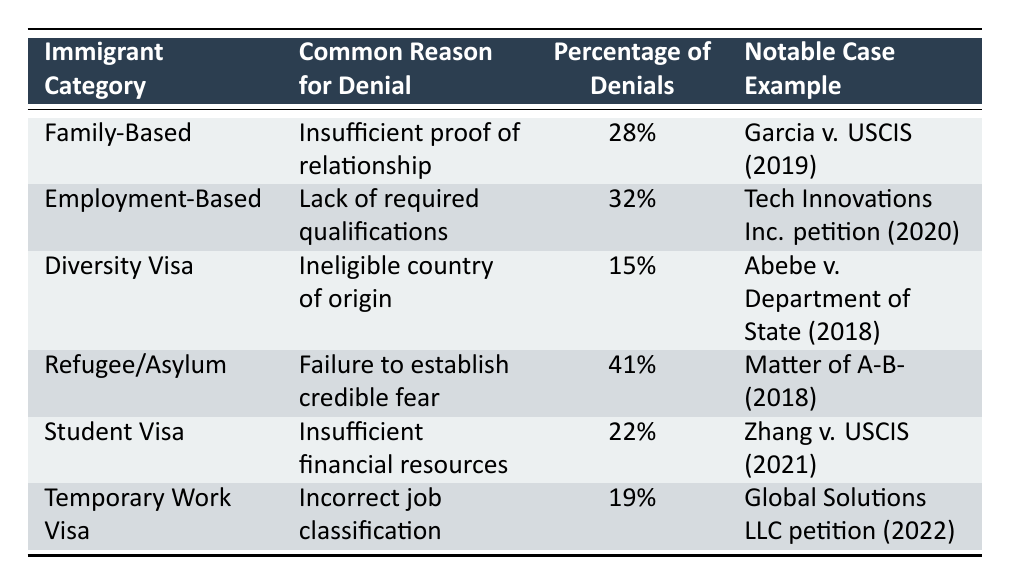What is the most common reason for visa denials in the Refugee/Asylum category? According to the table, the reason for denials in the Refugee/Asylum category is "Failure to establish credible fear."
Answer: Failure to establish credible fear Which immigrant category has the highest percentage of denials? The table shows that the Refugee/Asylum category has the highest percentage of denials at 41%.
Answer: Refugee/Asylum What percentage of Family-Based visa denials is due to insufficient proof of relationship? The table states that for the Family-Based category, the percentage of denials due to insufficient proof of relationship is 28%.
Answer: 28% Is the percentage of denials due to insufficient financial resources in the Student Visa category higher than that for the Diversity Visa category? The percentage for Student Visa is 22%, while for Diversity Visa it is 15%. Since 22% is greater than 15%, the answer is yes.
Answer: Yes What is the total percentage of denials for the Employment-Based and Temporary Work Visa categories? To find the total percentage, add the percentages of both categories: 32% (Employment-Based) + 19% (Temporary Work Visa) = 51%.
Answer: 51% Which notable case is associated with the lack of required qualifications in the Employment-Based category? The table indicates that the notable case for Employment-Based visa issues is "Tech Innovations Inc. petition (2020)."
Answer: Tech Innovations Inc. petition (2020) What category has the lowest percentage of visa denials? Reviewing the percentages, the Diversity Visa category has the lowest percentage of denials at 15%.
Answer: Diversity Visa If a Family-Based visa denial occurs, what is the likelihood that it is due to insufficient proof of relationship? The table states that 28% of Family-Based visa denials are due to insufficient proof of relationship, indicating a likelihood of 28%.
Answer: 28% Is “Incorrect job classification” a reason for denial in the Family-Based visa category? According to the table, "Incorrect job classification" is not listed as a reason for Family-Based visa denials; it is specific to the Temporary Work Visa category.
Answer: No What notable case example illustrates a denial due to ineligible country of origin? The table lists "Abebe v. Department of State (2018)" as the notable case for denials due to ineligible country of origin under the Diversity Visa category.
Answer: Abebe v. Department of State (2018) 